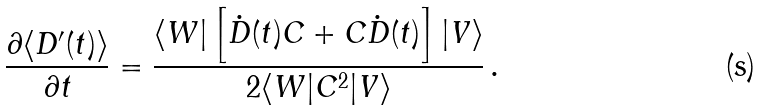<formula> <loc_0><loc_0><loc_500><loc_500>\frac { \partial \langle D ^ { \prime } ( t ) \rangle } { \partial t } = \frac { \langle W | \left [ \dot { D } ( t ) C + C \dot { D } ( t ) \right ] | V \rangle } { 2 \langle W | C ^ { 2 } | V \rangle } \, .</formula> 